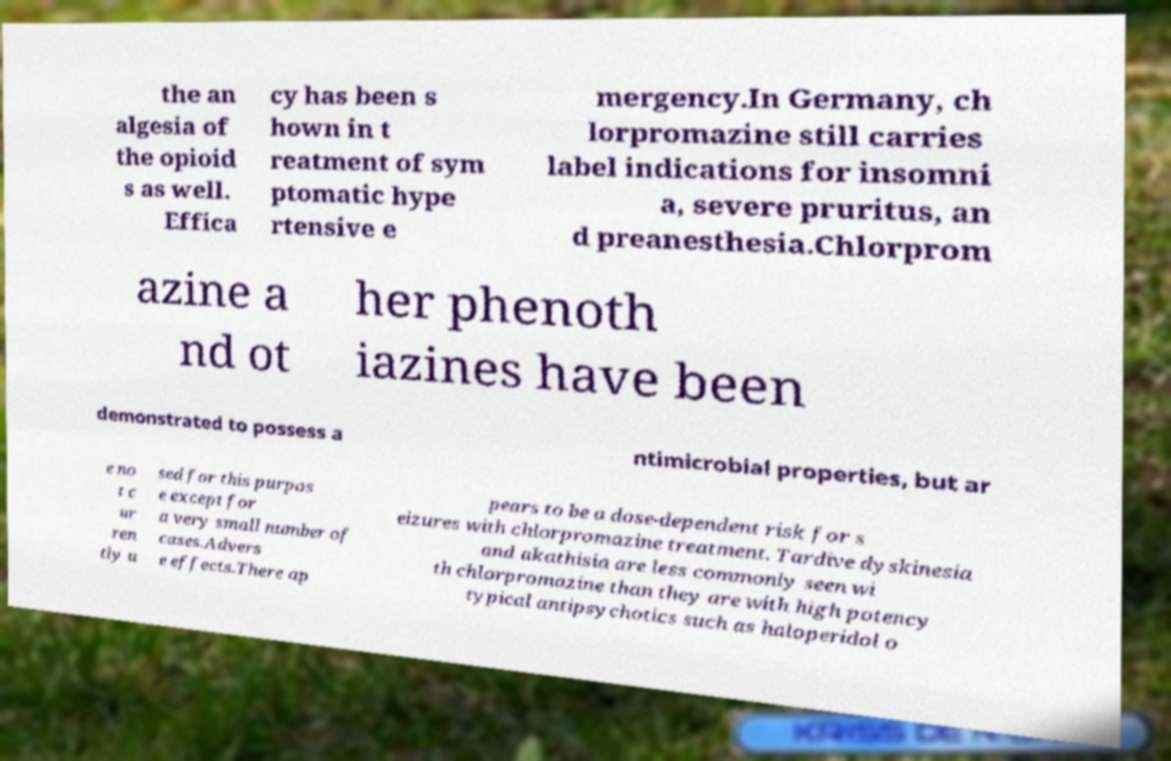There's text embedded in this image that I need extracted. Can you transcribe it verbatim? the an algesia of the opioid s as well. Effica cy has been s hown in t reatment of sym ptomatic hype rtensive e mergency.In Germany, ch lorpromazine still carries label indications for insomni a, severe pruritus, an d preanesthesia.Chlorprom azine a nd ot her phenoth iazines have been demonstrated to possess a ntimicrobial properties, but ar e no t c ur ren tly u sed for this purpos e except for a very small number of cases.Advers e effects.There ap pears to be a dose-dependent risk for s eizures with chlorpromazine treatment. Tardive dyskinesia and akathisia are less commonly seen wi th chlorpromazine than they are with high potency typical antipsychotics such as haloperidol o 